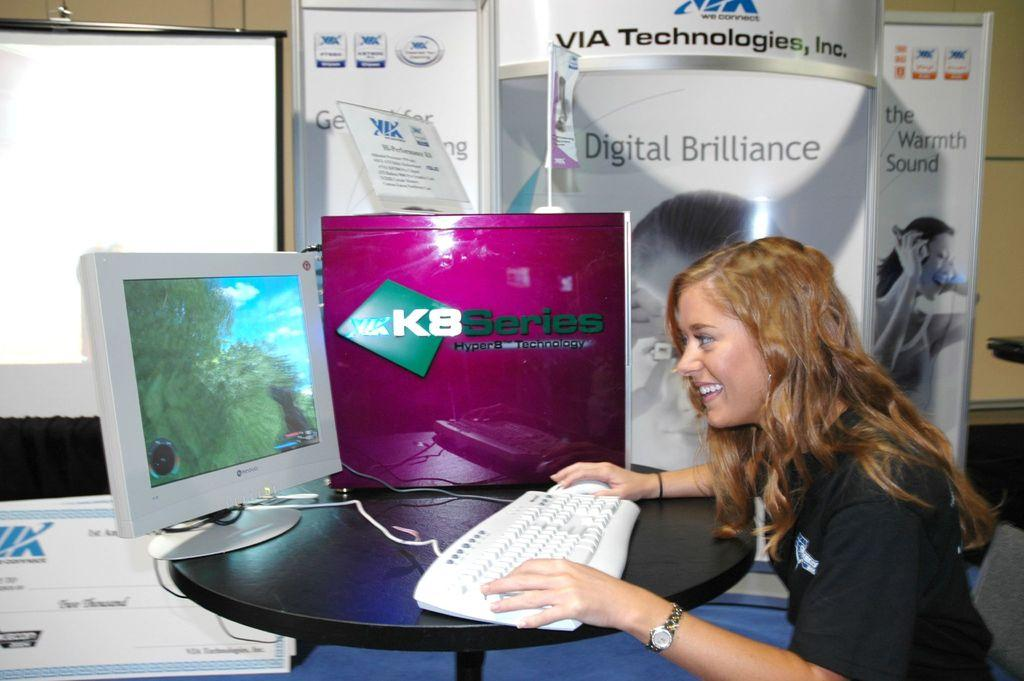Provide a one-sentence caption for the provided image. a woman sitting next to a sign that says 'digital brilliance'. 